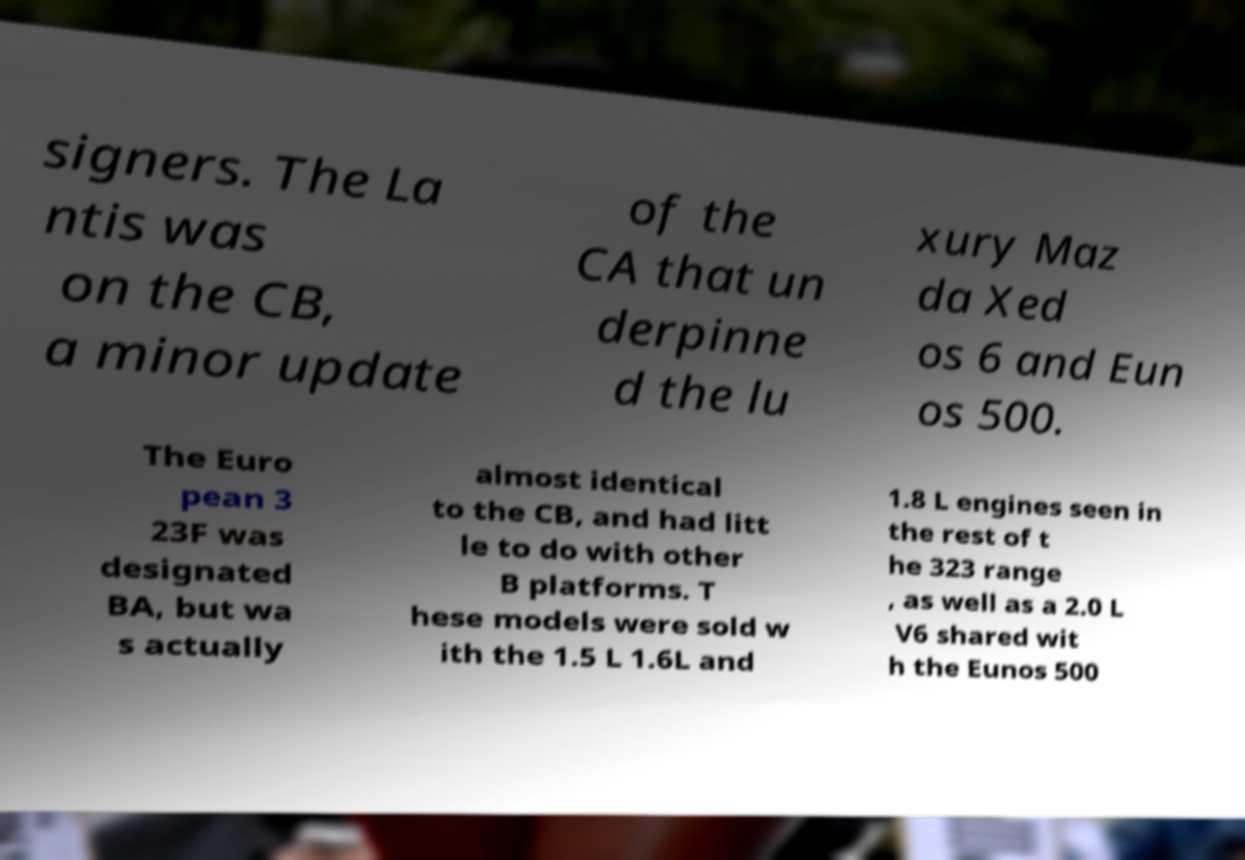What messages or text are displayed in this image? I need them in a readable, typed format. signers. The La ntis was on the CB, a minor update of the CA that un derpinne d the lu xury Maz da Xed os 6 and Eun os 500. The Euro pean 3 23F was designated BA, but wa s actually almost identical to the CB, and had litt le to do with other B platforms. T hese models were sold w ith the 1.5 L 1.6L and 1.8 L engines seen in the rest of t he 323 range , as well as a 2.0 L V6 shared wit h the Eunos 500 